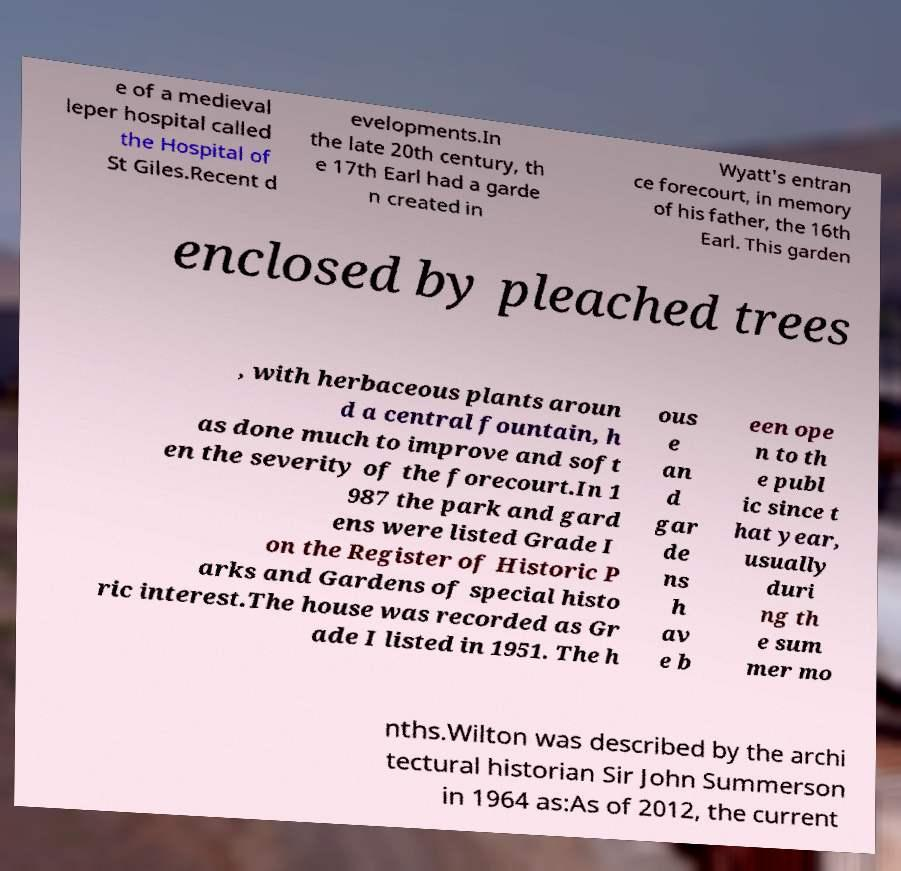For documentation purposes, I need the text within this image transcribed. Could you provide that? e of a medieval leper hospital called the Hospital of St Giles.Recent d evelopments.In the late 20th century, th e 17th Earl had a garde n created in Wyatt's entran ce forecourt, in memory of his father, the 16th Earl. This garden enclosed by pleached trees , with herbaceous plants aroun d a central fountain, h as done much to improve and soft en the severity of the forecourt.In 1 987 the park and gard ens were listed Grade I on the Register of Historic P arks and Gardens of special histo ric interest.The house was recorded as Gr ade I listed in 1951. The h ous e an d gar de ns h av e b een ope n to th e publ ic since t hat year, usually duri ng th e sum mer mo nths.Wilton was described by the archi tectural historian Sir John Summerson in 1964 as:As of 2012, the current 